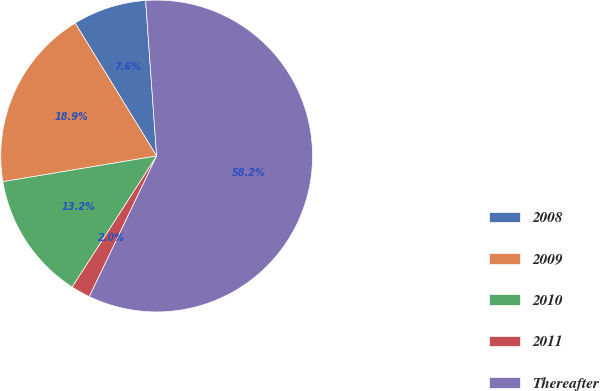<chart> <loc_0><loc_0><loc_500><loc_500><pie_chart><fcel>2008<fcel>2009<fcel>2010<fcel>2011<fcel>Thereafter<nl><fcel>7.63%<fcel>18.88%<fcel>13.25%<fcel>2.01%<fcel>58.23%<nl></chart> 